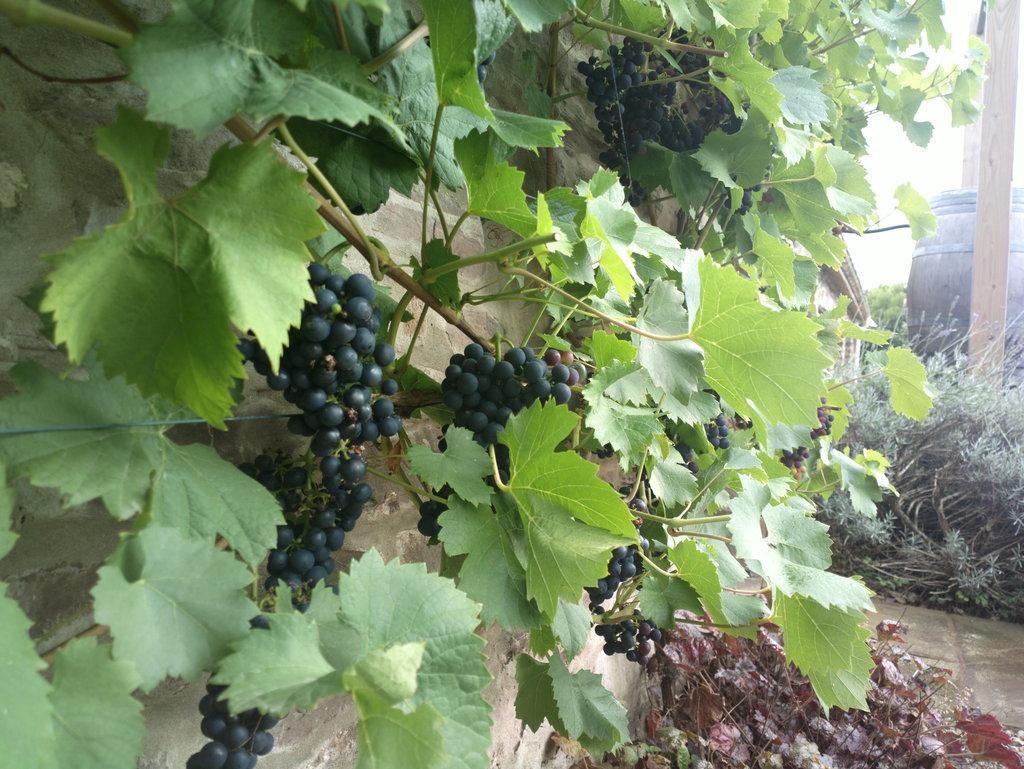Could you give a brief overview of what you see in this image? In this image we can see grapevine, in front of there are some plants, dry leaves and a barrel. 